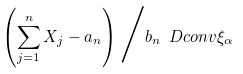<formula> <loc_0><loc_0><loc_500><loc_500>\left ( \sum _ { j = 1 } ^ { n } X _ { j } - a _ { n } \right ) \Big / b _ { n } \ D c o n v \xi _ { \alpha }</formula> 